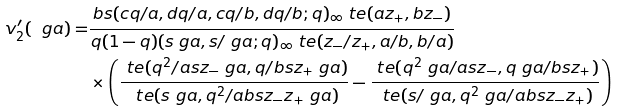Convert formula to latex. <formula><loc_0><loc_0><loc_500><loc_500>v _ { 2 } ^ { \prime } ( \ g a ) = & \frac { b s ( c q / a , d q / a , c q / b , d q / b ; q ) _ { \infty } \ t e ( a z _ { + } , b z _ { - } ) } { q ( 1 - q ) ( s \ g a , s / \ g a ; q ) _ { \infty } \ t e ( z _ { - } / z _ { + } , a / b , b / a ) } \\ & \times \left ( \frac { \ t e ( q ^ { 2 } / a s z _ { - } \ g a , q / b s z _ { + } \ g a ) } { \ t e ( s \ g a , q ^ { 2 } / a b s z _ { - } z _ { + } \ g a ) } - \frac { \ t e ( q ^ { 2 } \ g a / a s z _ { - } , q \ g a / b s z _ { + } ) } { \ t e ( s / \ g a , q ^ { 2 } \ g a / a b s z _ { - } z _ { + } ) } \right )</formula> 